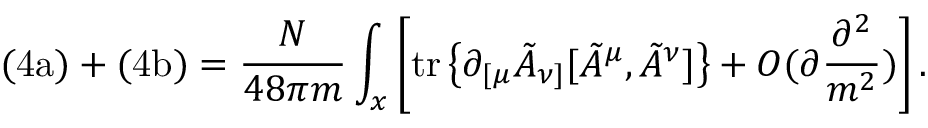Convert formula to latex. <formula><loc_0><loc_0><loc_500><loc_500>( 4 a ) + ( 4 b ) = \frac { N } { 4 8 \pi m } \int _ { x } \left [ t r \left \{ \partial _ { [ \mu } \tilde { A } _ { \nu ] } [ \tilde { A } ^ { \mu } , \tilde { A } ^ { \nu } ] \right \} + O ( \partial \frac { \partial ^ { 2 } } { m ^ { 2 } } ) \right ] .</formula> 